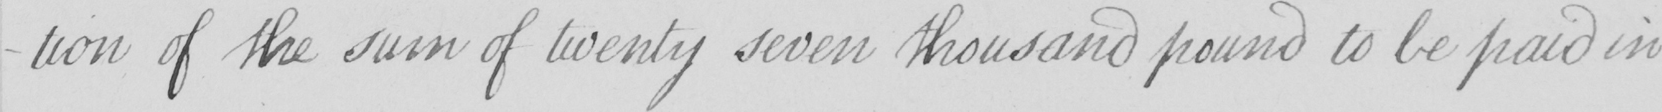What is written in this line of handwriting? -tion of the sum of twenty seven thousand pound to be paid in 